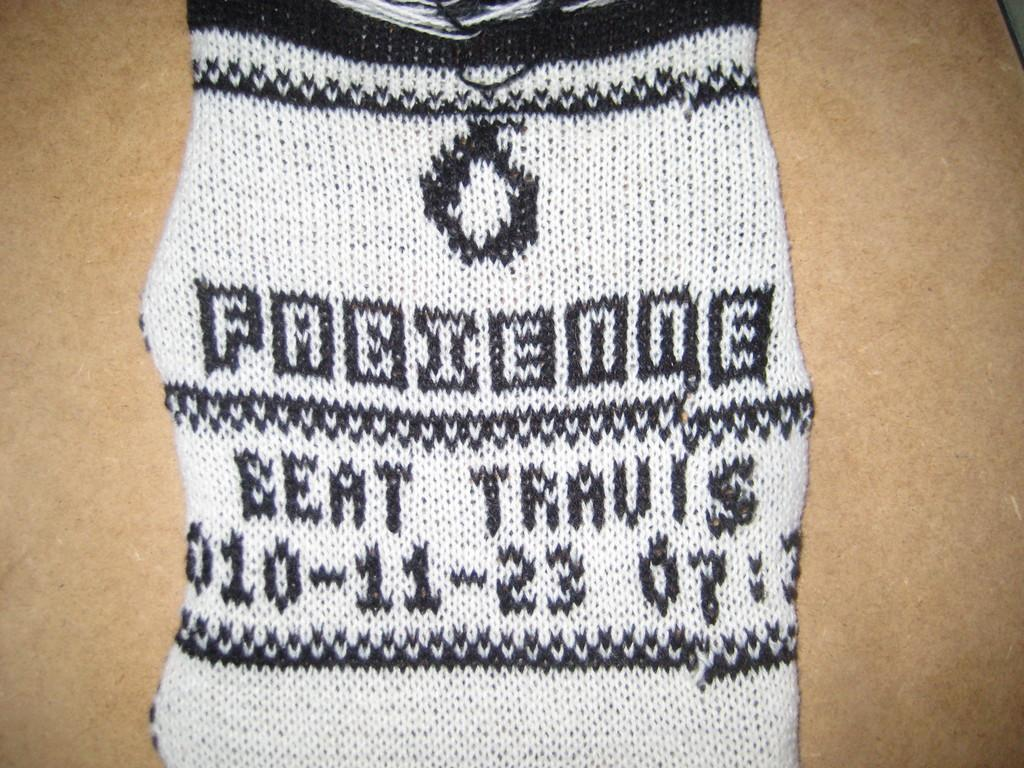What colors are present in the cloth shown in the image? The cloth is black and white in color. How many dinosaurs can be seen on the black and white cloth in the image? There are no dinosaurs present on the cloth in the image; it is a black and white cloth with no visible images or patterns. 